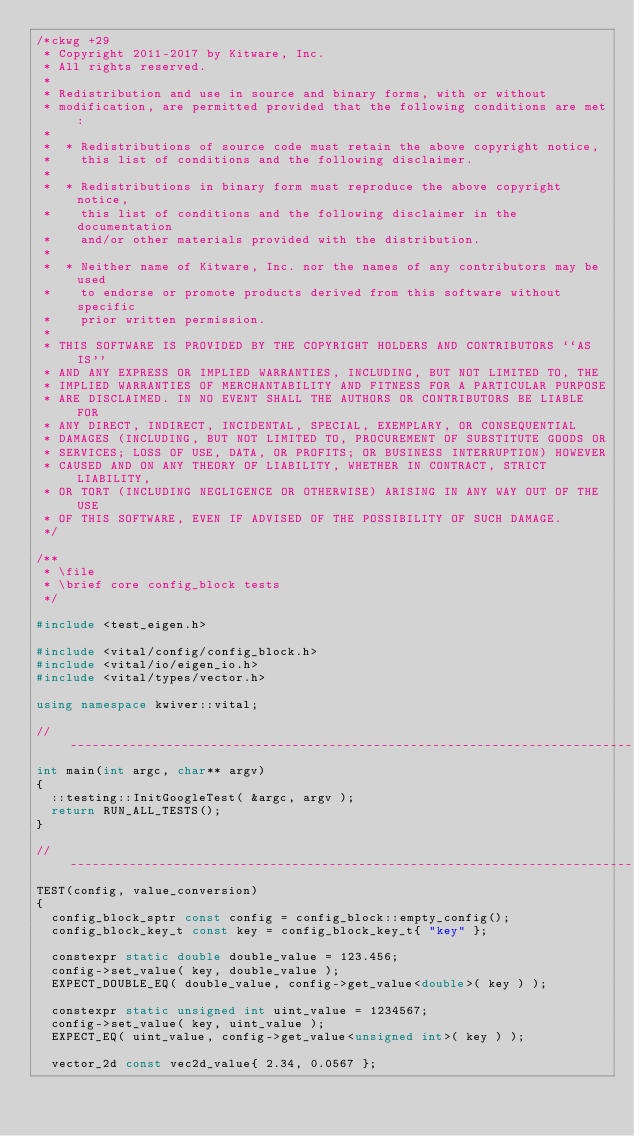Convert code to text. <code><loc_0><loc_0><loc_500><loc_500><_C++_>/*ckwg +29
 * Copyright 2011-2017 by Kitware, Inc.
 * All rights reserved.
 *
 * Redistribution and use in source and binary forms, with or without
 * modification, are permitted provided that the following conditions are met:
 *
 *  * Redistributions of source code must retain the above copyright notice,
 *    this list of conditions and the following disclaimer.
 *
 *  * Redistributions in binary form must reproduce the above copyright notice,
 *    this list of conditions and the following disclaimer in the documentation
 *    and/or other materials provided with the distribution.
 *
 *  * Neither name of Kitware, Inc. nor the names of any contributors may be used
 *    to endorse or promote products derived from this software without specific
 *    prior written permission.
 *
 * THIS SOFTWARE IS PROVIDED BY THE COPYRIGHT HOLDERS AND CONTRIBUTORS ``AS IS''
 * AND ANY EXPRESS OR IMPLIED WARRANTIES, INCLUDING, BUT NOT LIMITED TO, THE
 * IMPLIED WARRANTIES OF MERCHANTABILITY AND FITNESS FOR A PARTICULAR PURPOSE
 * ARE DISCLAIMED. IN NO EVENT SHALL THE AUTHORS OR CONTRIBUTORS BE LIABLE FOR
 * ANY DIRECT, INDIRECT, INCIDENTAL, SPECIAL, EXEMPLARY, OR CONSEQUENTIAL
 * DAMAGES (INCLUDING, BUT NOT LIMITED TO, PROCUREMENT OF SUBSTITUTE GOODS OR
 * SERVICES; LOSS OF USE, DATA, OR PROFITS; OR BUSINESS INTERRUPTION) HOWEVER
 * CAUSED AND ON ANY THEORY OF LIABILITY, WHETHER IN CONTRACT, STRICT LIABILITY,
 * OR TORT (INCLUDING NEGLIGENCE OR OTHERWISE) ARISING IN ANY WAY OUT OF THE USE
 * OF THIS SOFTWARE, EVEN IF ADVISED OF THE POSSIBILITY OF SUCH DAMAGE.
 */

/**
 * \file
 * \brief core config_block tests
 */

#include <test_eigen.h>

#include <vital/config/config_block.h>
#include <vital/io/eigen_io.h>
#include <vital/types/vector.h>

using namespace kwiver::vital;

// ----------------------------------------------------------------------------
int main(int argc, char** argv)
{
  ::testing::InitGoogleTest( &argc, argv );
  return RUN_ALL_TESTS();
}

// ----------------------------------------------------------------------------
TEST(config, value_conversion)
{
  config_block_sptr const config = config_block::empty_config();
  config_block_key_t const key = config_block_key_t{ "key" };

  constexpr static double double_value = 123.456;
  config->set_value( key, double_value );
  EXPECT_DOUBLE_EQ( double_value, config->get_value<double>( key ) );

  constexpr static unsigned int uint_value = 1234567;
  config->set_value( key, uint_value );
  EXPECT_EQ( uint_value, config->get_value<unsigned int>( key ) );

  vector_2d const vec2d_value{ 2.34, 0.0567 };</code> 